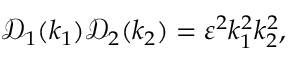<formula> <loc_0><loc_0><loc_500><loc_500>\mathcal { D } _ { 1 } ( k _ { 1 } ) \mathcal { D } _ { 2 } ( k _ { 2 } ) = \varepsilon ^ { 2 } k _ { 1 } ^ { 2 } k _ { 2 } ^ { 2 } ,</formula> 